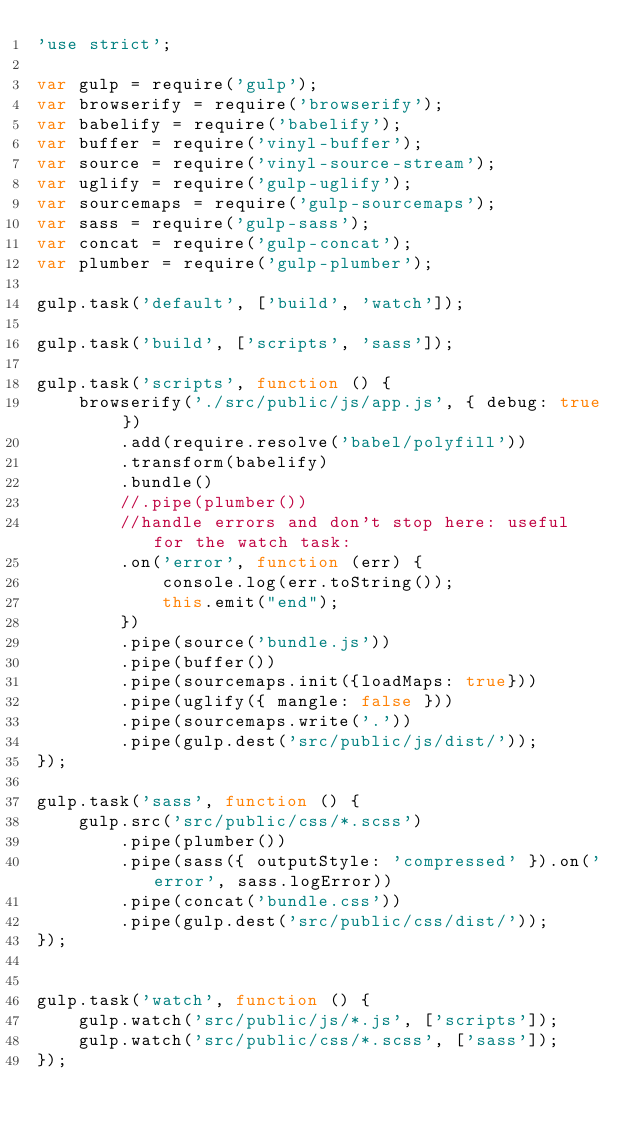Convert code to text. <code><loc_0><loc_0><loc_500><loc_500><_JavaScript_>'use strict';

var gulp = require('gulp');
var browserify = require('browserify');
var babelify = require('babelify');
var buffer = require('vinyl-buffer');
var source = require('vinyl-source-stream');
var uglify = require('gulp-uglify');
var sourcemaps = require('gulp-sourcemaps');
var sass = require('gulp-sass');
var concat = require('gulp-concat');
var plumber = require('gulp-plumber');

gulp.task('default', ['build', 'watch']);

gulp.task('build', ['scripts', 'sass']);

gulp.task('scripts', function () {
    browserify('./src/public/js/app.js', { debug: true })
        .add(require.resolve('babel/polyfill'))
        .transform(babelify)
        .bundle()
        //.pipe(plumber())
        //handle errors and don't stop here: useful for the watch task:
        .on('error', function (err) {
            console.log(err.toString());
            this.emit("end");
        })
        .pipe(source('bundle.js'))
        .pipe(buffer())
        .pipe(sourcemaps.init({loadMaps: true}))
        .pipe(uglify({ mangle: false }))
        .pipe(sourcemaps.write('.'))
        .pipe(gulp.dest('src/public/js/dist/'));
});

gulp.task('sass', function () {
    gulp.src('src/public/css/*.scss')
        .pipe(plumber())
        .pipe(sass({ outputStyle: 'compressed' }).on('error', sass.logError))
        .pipe(concat('bundle.css'))
        .pipe(gulp.dest('src/public/css/dist/'));
});


gulp.task('watch', function () {
    gulp.watch('src/public/js/*.js', ['scripts']);
    gulp.watch('src/public/css/*.scss', ['sass']);
});
</code> 